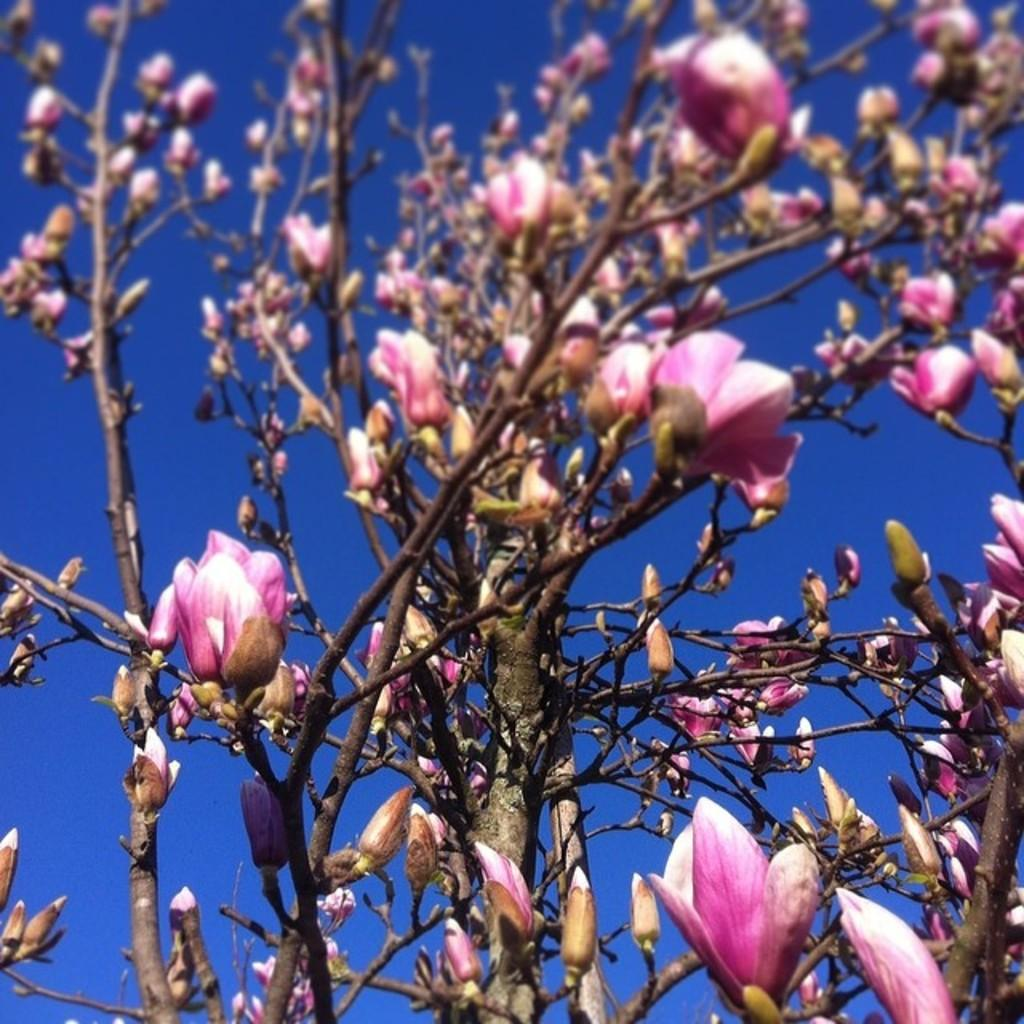What type of living organism is in the picture? There is a plant in the picture. What color are the flowers on the plant? The flowers on the plant are pink in color. Are there any unopened flowers on the plant? Yes, the plant has flower buds. What can be seen behind the plant in the image? The sky is visible behind the plant. What is the color of the sky in the image? The sky is blue in color. Can you see any fish swimming in the sky in the image? No, there are no fish visible in the image, and the sky is not a body of water where fish would swim. 